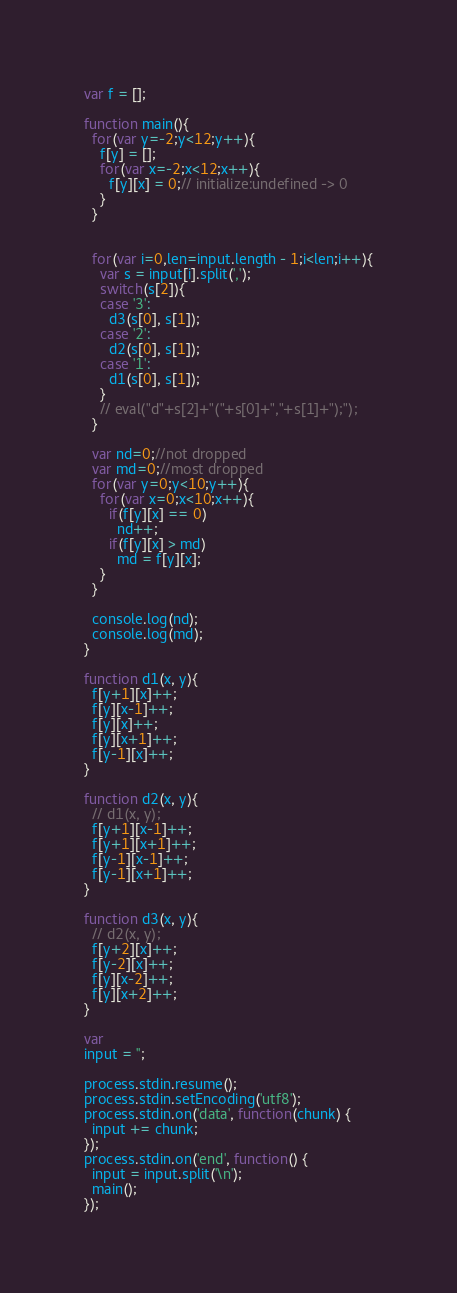Convert code to text. <code><loc_0><loc_0><loc_500><loc_500><_JavaScript_>var f = [];

function main(){
  for(var y=-2;y<12;y++){
    f[y] = [];
    for(var x=-2;x<12;x++){
      f[y][x] = 0;// initialize:undefined -> 0
    }
  }

  
  for(var i=0,len=input.length - 1;i<len;i++){
    var s = input[i].split(',');
    switch(s[2]){
    case '3':
      d3(s[0], s[1]);
    case '2':
      d2(s[0], s[1]);
    case '1':
      d1(s[0], s[1]);
    }
    // eval("d"+s[2]+"("+s[0]+","+s[1]+");");
  }

  var nd=0;//not dropped
  var md=0;//most dropped
  for(var y=0;y<10;y++){
    for(var x=0;x<10;x++){
      if(f[y][x] == 0)
        nd++;
      if(f[y][x] > md)
        md = f[y][x];
    }
  }

  console.log(nd);
  console.log(md);
}

function d1(x, y){
  f[y+1][x]++;
  f[y][x-1]++;
  f[y][x]++;
  f[y][x+1]++;
  f[y-1][x]++;
}

function d2(x, y){
  // d1(x, y);
  f[y+1][x-1]++;
  f[y+1][x+1]++;
  f[y-1][x-1]++;
  f[y-1][x+1]++;
}

function d3(x, y){
  // d2(x, y);
  f[y+2][x]++;
  f[y-2][x]++;
  f[y][x-2]++;
  f[y][x+2]++;
}

var
input = '';

process.stdin.resume();
process.stdin.setEncoding('utf8');
process.stdin.on('data', function(chunk) {
  input += chunk;
});
process.stdin.on('end', function() {
  input = input.split('\n');
  main();
});</code> 